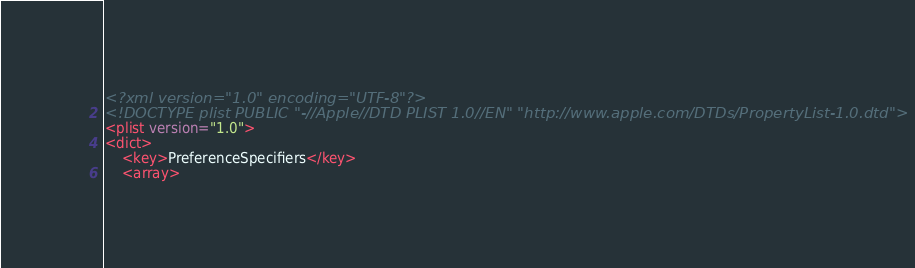Convert code to text. <code><loc_0><loc_0><loc_500><loc_500><_XML_><?xml version="1.0" encoding="UTF-8"?>
<!DOCTYPE plist PUBLIC "-//Apple//DTD PLIST 1.0//EN" "http://www.apple.com/DTDs/PropertyList-1.0.dtd">
<plist version="1.0">
<dict>
	<key>PreferenceSpecifiers</key>
	<array></code> 